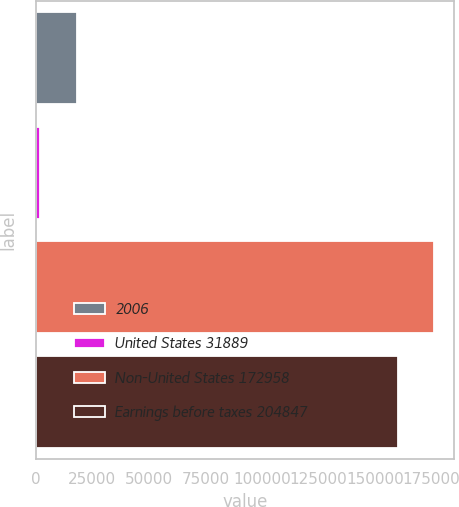Convert chart to OTSL. <chart><loc_0><loc_0><loc_500><loc_500><bar_chart><fcel>2006<fcel>United States 31889<fcel>Non-United States 172958<fcel>Earnings before taxes 204847<nl><fcel>17973.4<fcel>1955<fcel>176202<fcel>160184<nl></chart> 